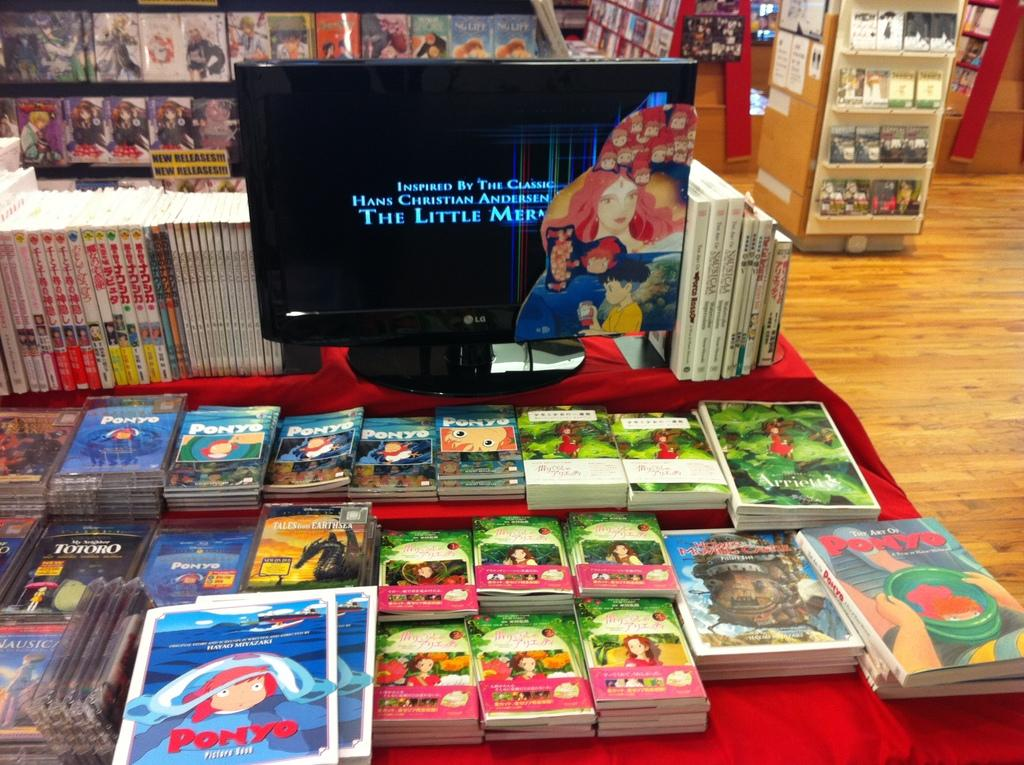<image>
Offer a succinct explanation of the picture presented. Table full of many books including one that says "Ponyo". 